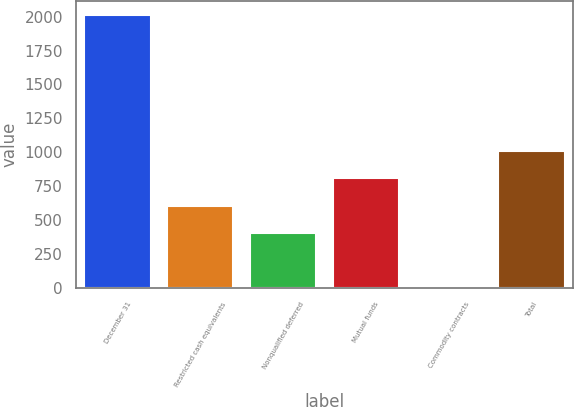<chart> <loc_0><loc_0><loc_500><loc_500><bar_chart><fcel>December 31<fcel>Restricted cash equivalents<fcel>Nonqualified deferred<fcel>Mutual funds<fcel>Commodity contracts<fcel>Total<nl><fcel>2013<fcel>607.4<fcel>406.6<fcel>808.2<fcel>5<fcel>1009<nl></chart> 